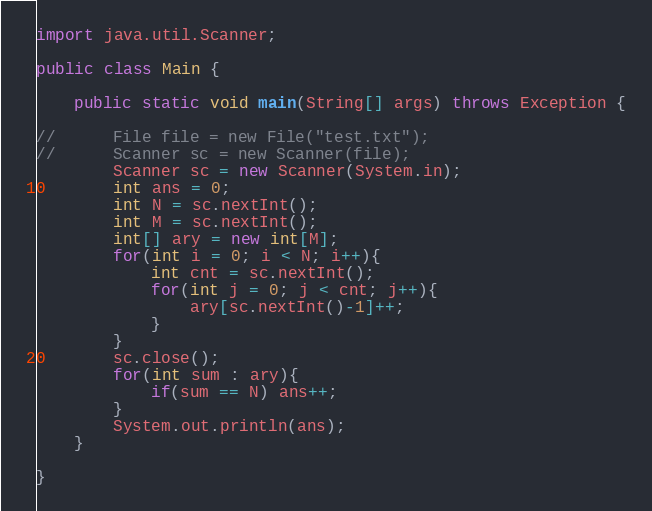<code> <loc_0><loc_0><loc_500><loc_500><_Java_>import java.util.Scanner;

public class Main {

    public static void main(String[] args) throws Exception {

//    	File file = new File("test.txt");
//    	Scanner sc = new Scanner(file);
    	Scanner sc = new Scanner(System.in);
    	int ans = 0;
    	int N = sc.nextInt();
    	int M = sc.nextInt();
    	int[] ary = new int[M];
    	for(int i = 0; i < N; i++){
    		int cnt = sc.nextInt();
    		for(int j = 0; j < cnt; j++){
    			ary[sc.nextInt()-1]++;
    		}
    	}
    	sc.close();
    	for(int sum : ary){
    		if(sum == N) ans++;
    	}
    	System.out.println(ans);
    }

}
</code> 